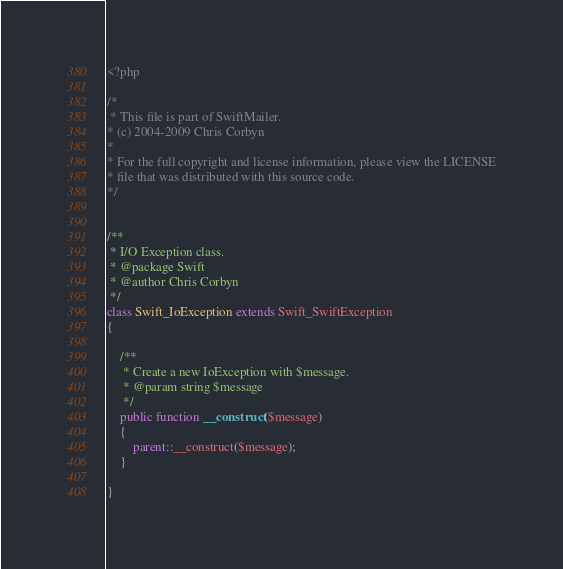<code> <loc_0><loc_0><loc_500><loc_500><_PHP_><?php

/*
 * This file is part of SwiftMailer.
* (c) 2004-2009 Chris Corbyn
*
* For the full copyright and license information, please view the LICENSE
* file that was distributed with this source code.
*/


/**
 * I/O Exception class.
 * @package Swift
 * @author Chris Corbyn
 */
class Swift_IoException extends Swift_SwiftException
{

	/**
	 * Create a new IoException with $message.
	 * @param string $message
	 */
	public function __construct($message)
	{
		parent::__construct($message);
	}

}
</code> 